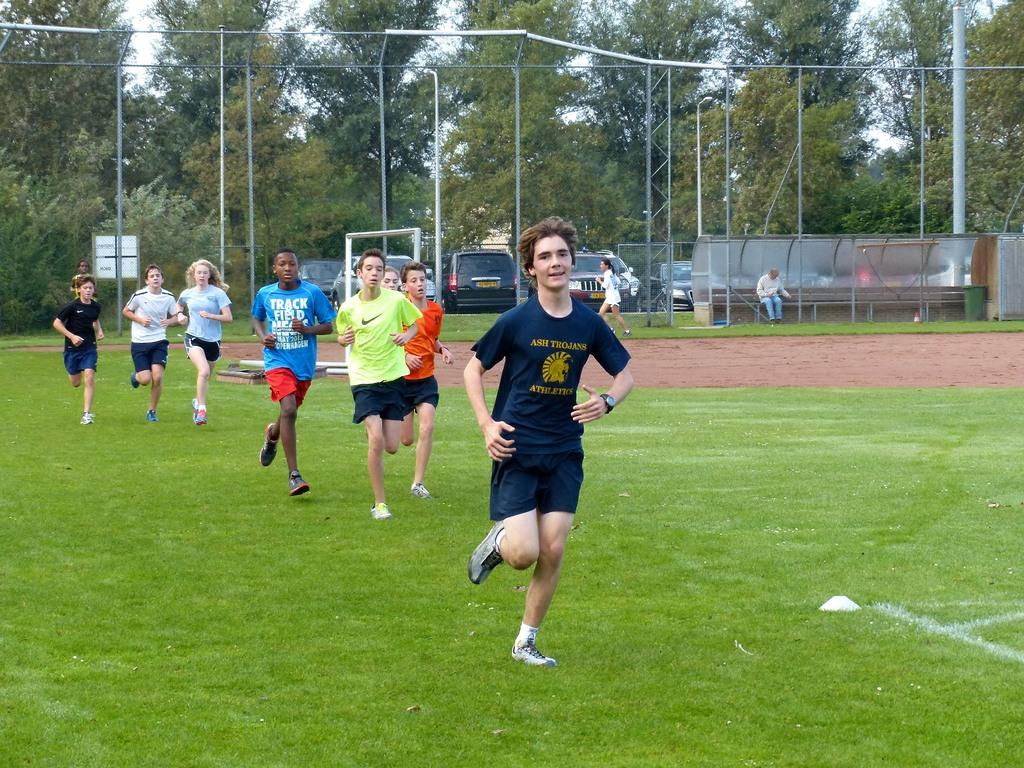<image>
Present a compact description of the photo's key features. A kid with a track and field shirt is running with others. 